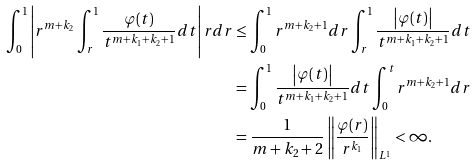<formula> <loc_0><loc_0><loc_500><loc_500>\int _ { 0 } ^ { 1 } \left | r ^ { m + k _ { 2 } } \int ^ { 1 } _ { r } { \frac { \varphi ( t ) } { t ^ { m + k _ { 1 } + k _ { 2 } + 1 } } } { d t } \right | r d r & \leq \int _ { 0 } ^ { 1 } { r ^ { m + k _ { 2 } + 1 } d r \int ^ { 1 } _ { r } { \frac { \left | \varphi ( t ) \right | } { t ^ { m + k _ { 1 } + k _ { 2 } + 1 } } } { d t } } \\ & = \int _ { 0 } ^ { 1 } \frac { \left | \varphi ( t ) \right | } { t ^ { m + k _ { 1 } + k _ { 2 } + 1 } } { d t } \int _ { 0 } ^ { t } r ^ { m + k _ { 2 } + 1 } d r \\ & = \frac { 1 } { m + k _ { 2 } + 2 } \left \| \frac { \varphi ( r ) } { r ^ { k _ { 1 } } } \right \| _ { L ^ { 1 } } < \infty .</formula> 